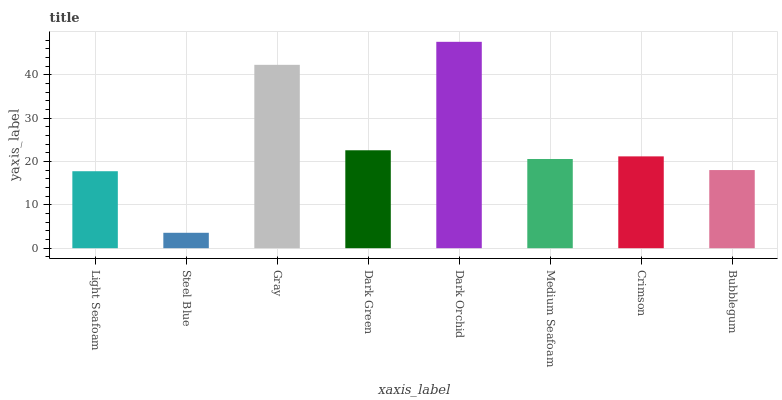Is Steel Blue the minimum?
Answer yes or no. Yes. Is Dark Orchid the maximum?
Answer yes or no. Yes. Is Gray the minimum?
Answer yes or no. No. Is Gray the maximum?
Answer yes or no. No. Is Gray greater than Steel Blue?
Answer yes or no. Yes. Is Steel Blue less than Gray?
Answer yes or no. Yes. Is Steel Blue greater than Gray?
Answer yes or no. No. Is Gray less than Steel Blue?
Answer yes or no. No. Is Crimson the high median?
Answer yes or no. Yes. Is Medium Seafoam the low median?
Answer yes or no. Yes. Is Dark Orchid the high median?
Answer yes or no. No. Is Dark Orchid the low median?
Answer yes or no. No. 